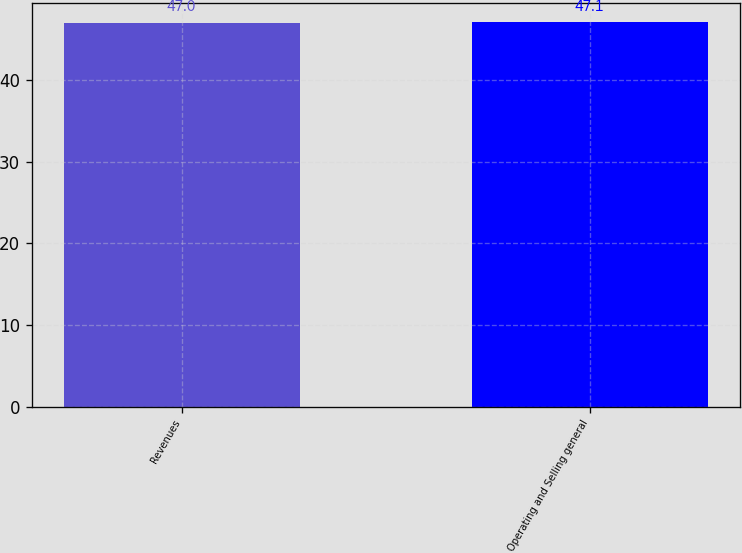<chart> <loc_0><loc_0><loc_500><loc_500><bar_chart><fcel>Revenues<fcel>Operating and Selling general<nl><fcel>47<fcel>47.1<nl></chart> 